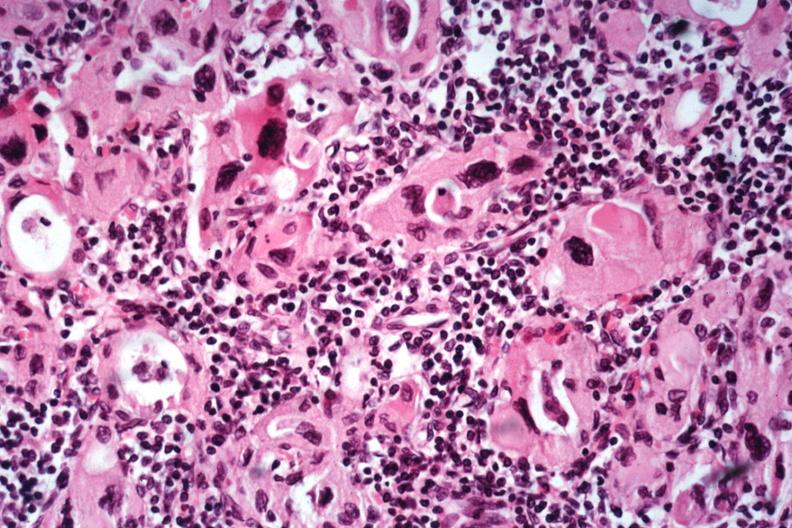what is present?
Answer the question using a single word or phrase. Autoimmune thyroiditis 